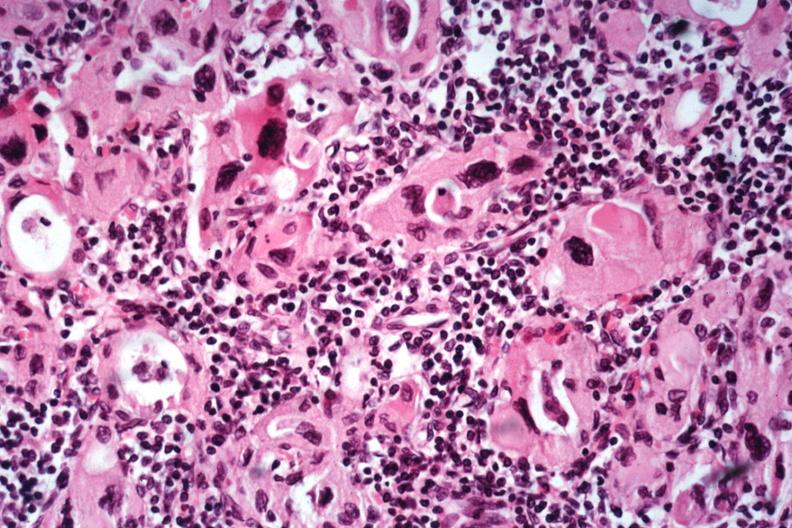what is present?
Answer the question using a single word or phrase. Autoimmune thyroiditis 